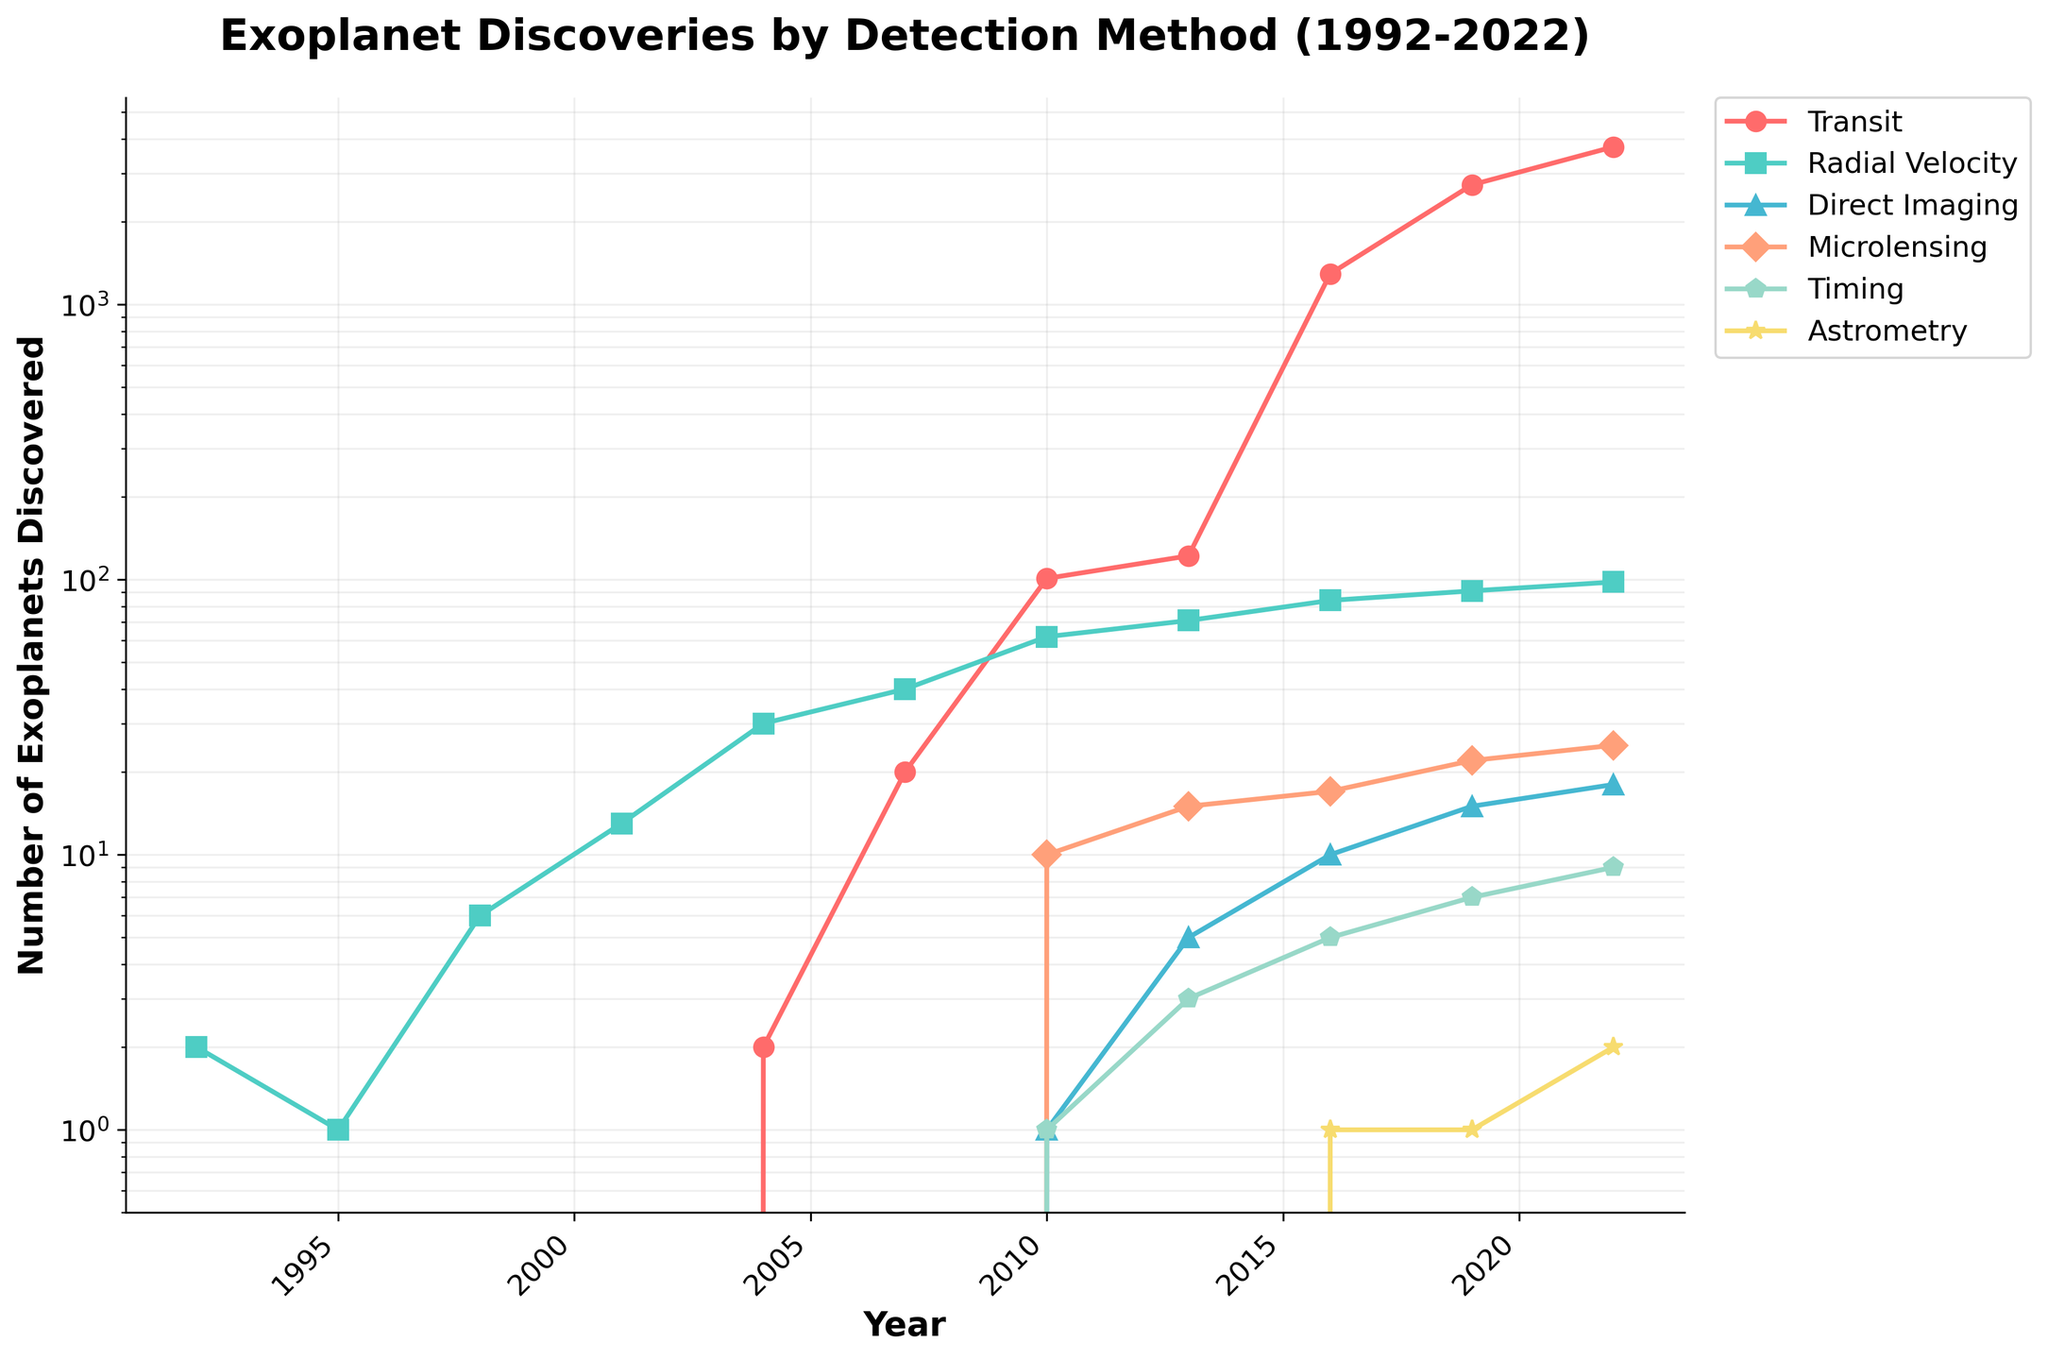What's the most popular detection method for exoplanets in 2022? The highest line in 2022 is for the Transit detection method, which means most exoplanets were discovered using this method.
Answer: Transit How many exoplanets were discovered using the Radial Velocity method in 2010? Locate the Radial Velocity line in the year 2010 and see the corresponding y-axis value; it is 62 exoplanets.
Answer: 62 In which year did the Transit method first become the leading method for detecting exoplanets? The Transit method overtakes other methods in 2007 where it surpasses the Radial Velocity line.
Answer: 2007 What is the second most popular detection method in 2019? In 2019, the Radial Velocity method's line is the second highest after Transit.
Answer: Radial Velocity How many more exoplanets were discovered using the Transit method in 2016 compared to 2013? The number of exoplanets discovered via the Transit method in 2016 is 1293 and in 2013 is 122. The difference is 1293 - 122 = 1171.
Answer: 1171 Which detection methods had visual representations starting in 2010? In 2010, lines for Direct Imaging, Microlensing, and Timing appear, indicating their start.
Answer: Direct Imaging, Microlensing, Timing Compare the number of exoplanets discovered by Direct Imaging and Microlensing in 2022. Which is higher? In 2022, Direct Imaging discovered 18 exoplanets, and Microlensing discovered 25. Therefore, Microlensing is higher.
Answer: Microlensing What is the average number of exoplanets discovered per year using the Astrometry method if its first discovery was in 2016? Astrometry has discoveries in 2016, 2019, and 2022 as 1, 1, and 2 respectively. Average: (1 + 1 + 2) / 3 = 1.33.
Answer: 1.33 What can you infer about the number of exoplanets discovered using the Timing method between 2007 and 2010? The Timing method line first appears in 2010 with 1 exoplanet discovered and there is no count in 2007, indicating no discoveries before 2010.
Answer: No discoveries How has the trend in the number of exoplanets discovered by Microlensing changed from 2010 to 2022? The line for Microlensing shows a gradual increase in the number of exoplanets discovered from 10 in 2010 to 25 in 2022.
Answer: Gradual increase 